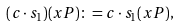<formula> <loc_0><loc_0><loc_500><loc_500>( c \cdot s _ { 1 } ) ( x P ) \colon = c \cdot s _ { 1 } ( x P ) ,</formula> 